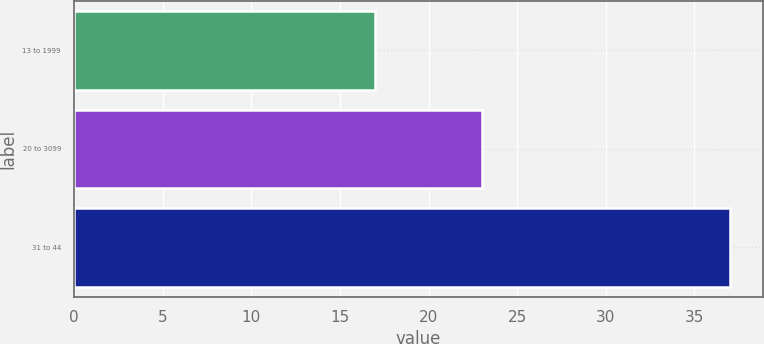Convert chart. <chart><loc_0><loc_0><loc_500><loc_500><bar_chart><fcel>13 to 1999<fcel>20 to 3099<fcel>31 to 44<nl><fcel>17<fcel>23<fcel>37<nl></chart> 